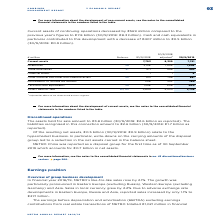According to Metro Ag's financial document, What was the amount of current assets of continuing operations in FY2019? According to the financial document, 7,761 (in millions). The relevant text states: "Current assets 7,703 8,329 7,761..." Also, What was the amount of cash and cash equivalents in FY2019? According to the financial document, 500 (in millions). The relevant text states: "Cash and cash equivalents 29 1,298 906 500..." Also, In which years were the current assets of continuing operations calculated in? The document shows two values: 2019 and 2018. From the document: "adjusted 1 30/9/2019 previous year's figures to €7.8 billion (30/9/2018: €8.3 billion). Cash and cash equivalents in..." Additionally, In which year was the amount of Trade Receivables larger for the FY2018 adjusted figure and FY2019 figures? Based on the financial document, the answer is 2018 adjusted. Also, can you calculate: What was the change in Cash and cash equivalents in FY2019 from FY2018 adjusted? Based on the calculation: 500-906, the result is -406 (in millions). This is based on the information: "Cash and cash equivalents 29 1,298 906 500 Cash and cash equivalents 29 1,298 906 500..." The key data points involved are: 500, 906. Also, can you calculate: What was the percentage change in Cash and cash equivalents in FY2019 from FY2018 adjusted? To answer this question, I need to perform calculations using the financial data. The calculation is: (500-906)/906, which equals -44.81 (percentage). This is based on the information: "Cash and cash equivalents 29 1,298 906 500 Cash and cash equivalents 29 1,298 906 500..." The key data points involved are: 500, 906. 